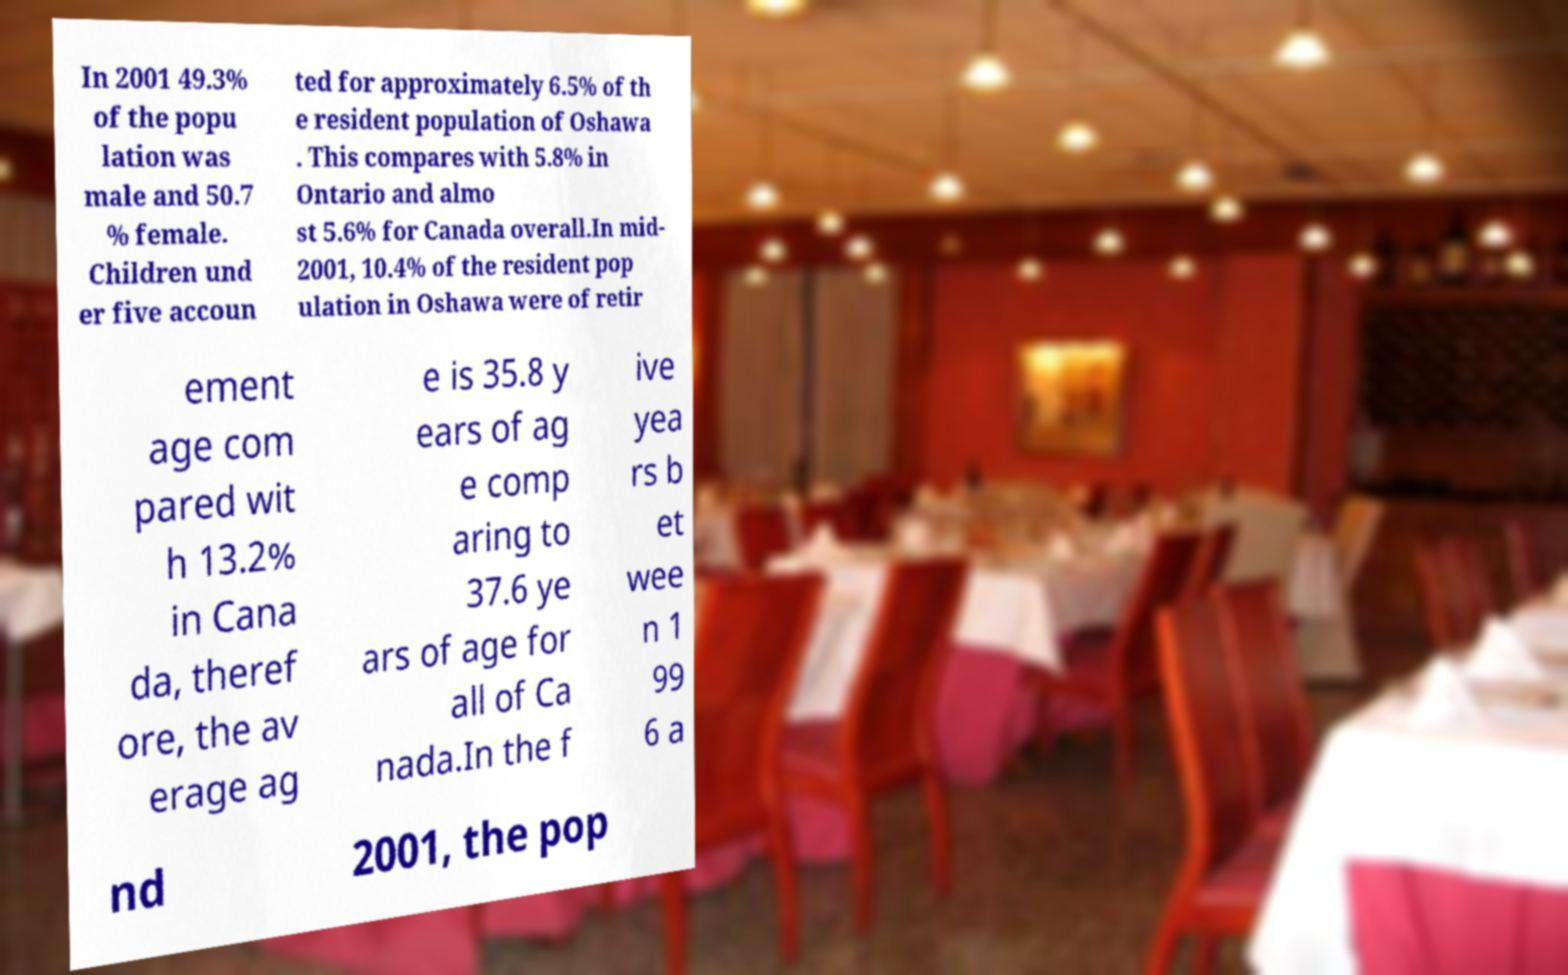Could you assist in decoding the text presented in this image and type it out clearly? In 2001 49.3% of the popu lation was male and 50.7 % female. Children und er five accoun ted for approximately 6.5% of th e resident population of Oshawa . This compares with 5.8% in Ontario and almo st 5.6% for Canada overall.In mid- 2001, 10.4% of the resident pop ulation in Oshawa were of retir ement age com pared wit h 13.2% in Cana da, theref ore, the av erage ag e is 35.8 y ears of ag e comp aring to 37.6 ye ars of age for all of Ca nada.In the f ive yea rs b et wee n 1 99 6 a nd 2001, the pop 